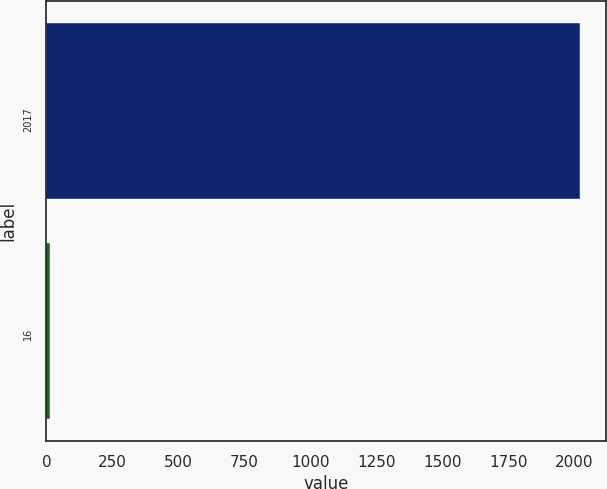Convert chart. <chart><loc_0><loc_0><loc_500><loc_500><bar_chart><fcel>2017<fcel>16<nl><fcel>2020<fcel>14<nl></chart> 